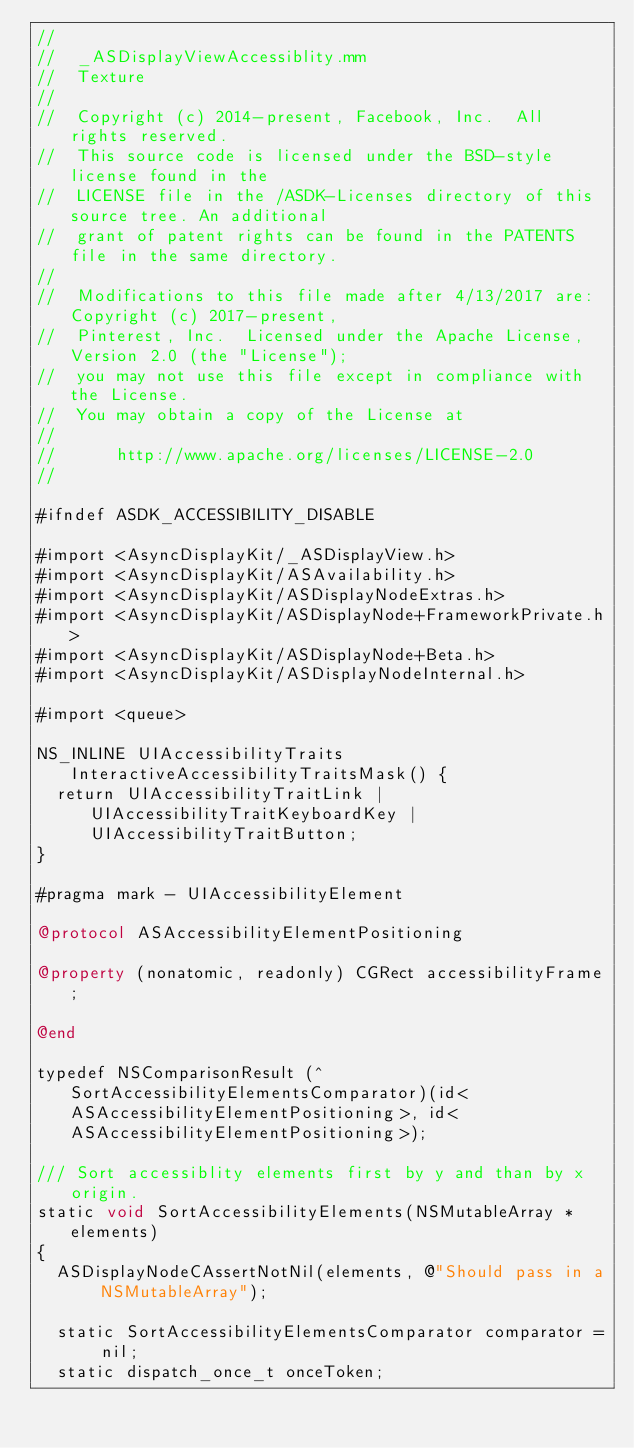Convert code to text. <code><loc_0><loc_0><loc_500><loc_500><_ObjectiveC_>//
//  _ASDisplayViewAccessiblity.mm
//  Texture
//
//  Copyright (c) 2014-present, Facebook, Inc.  All rights reserved.
//  This source code is licensed under the BSD-style license found in the
//  LICENSE file in the /ASDK-Licenses directory of this source tree. An additional
//  grant of patent rights can be found in the PATENTS file in the same directory.
//
//  Modifications to this file made after 4/13/2017 are: Copyright (c) 2017-present,
//  Pinterest, Inc.  Licensed under the Apache License, Version 2.0 (the "License");
//  you may not use this file except in compliance with the License.
//  You may obtain a copy of the License at
//
//      http://www.apache.org/licenses/LICENSE-2.0
//

#ifndef ASDK_ACCESSIBILITY_DISABLE

#import <AsyncDisplayKit/_ASDisplayView.h>
#import <AsyncDisplayKit/ASAvailability.h>
#import <AsyncDisplayKit/ASDisplayNodeExtras.h>
#import <AsyncDisplayKit/ASDisplayNode+FrameworkPrivate.h>
#import <AsyncDisplayKit/ASDisplayNode+Beta.h>
#import <AsyncDisplayKit/ASDisplayNodeInternal.h>

#import <queue>

NS_INLINE UIAccessibilityTraits InteractiveAccessibilityTraitsMask() {
  return UIAccessibilityTraitLink | UIAccessibilityTraitKeyboardKey | UIAccessibilityTraitButton;
}

#pragma mark - UIAccessibilityElement

@protocol ASAccessibilityElementPositioning

@property (nonatomic, readonly) CGRect accessibilityFrame;

@end

typedef NSComparisonResult (^SortAccessibilityElementsComparator)(id<ASAccessibilityElementPositioning>, id<ASAccessibilityElementPositioning>);

/// Sort accessiblity elements first by y and than by x origin.
static void SortAccessibilityElements(NSMutableArray *elements)
{
  ASDisplayNodeCAssertNotNil(elements, @"Should pass in a NSMutableArray");
  
  static SortAccessibilityElementsComparator comparator = nil;
  static dispatch_once_t onceToken;</code> 